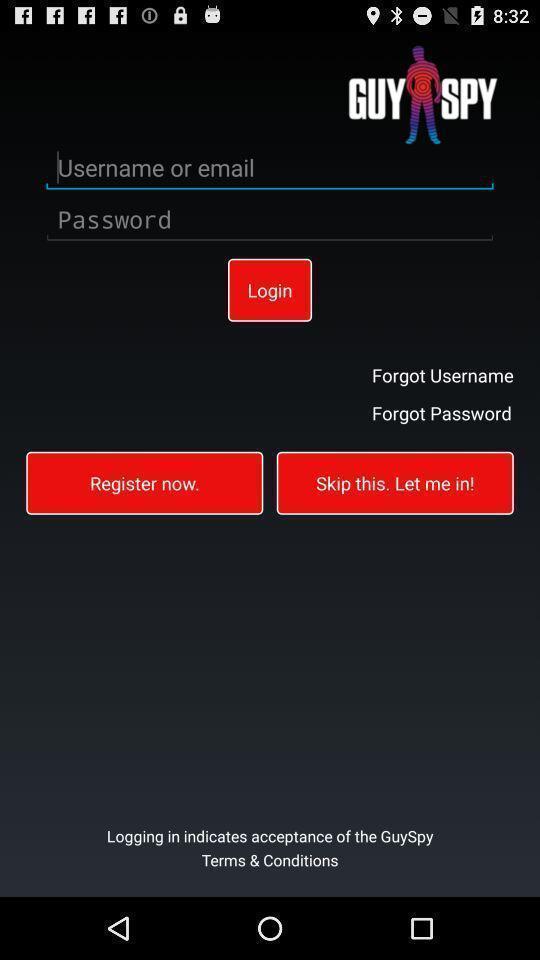What details can you identify in this image? Page showing an account to register. 